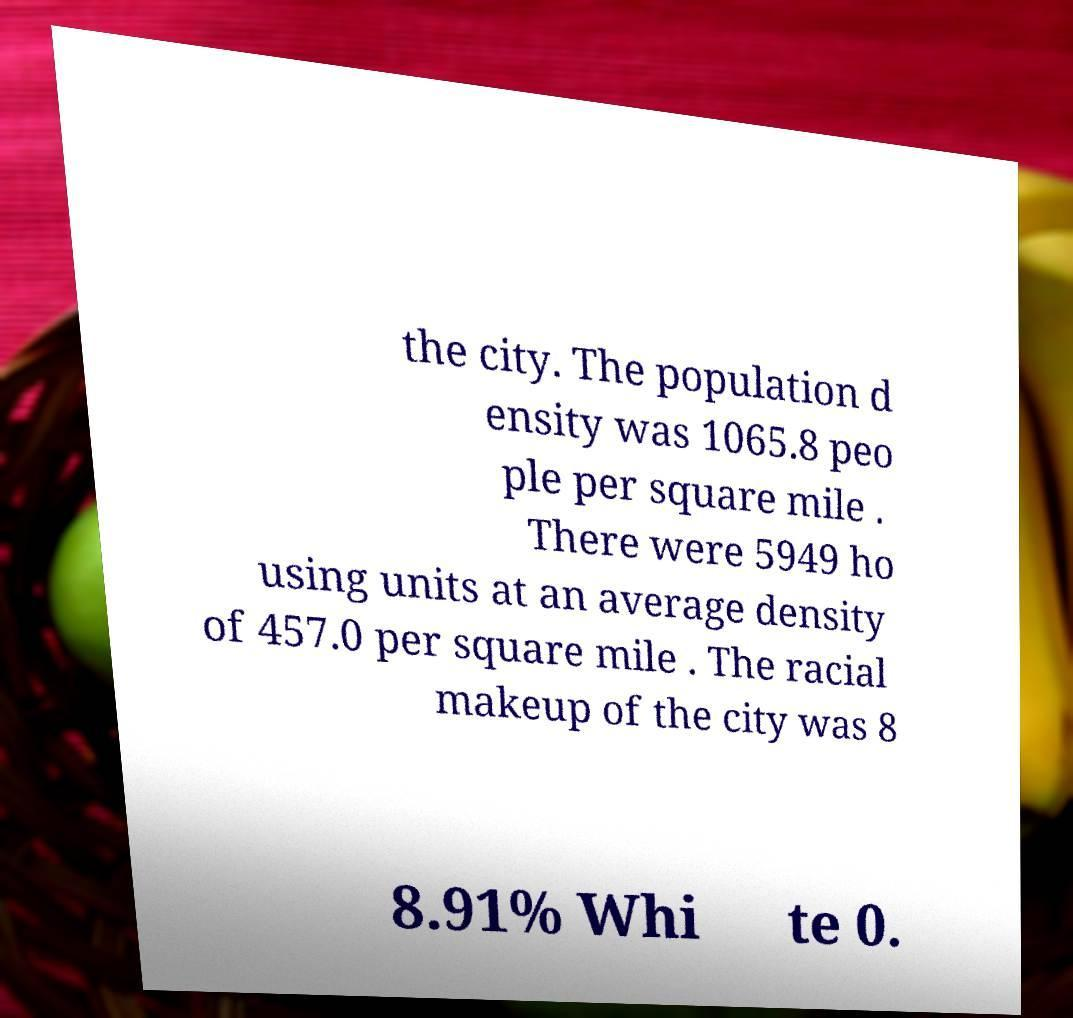For documentation purposes, I need the text within this image transcribed. Could you provide that? the city. The population d ensity was 1065.8 peo ple per square mile . There were 5949 ho using units at an average density of 457.0 per square mile . The racial makeup of the city was 8 8.91% Whi te 0. 